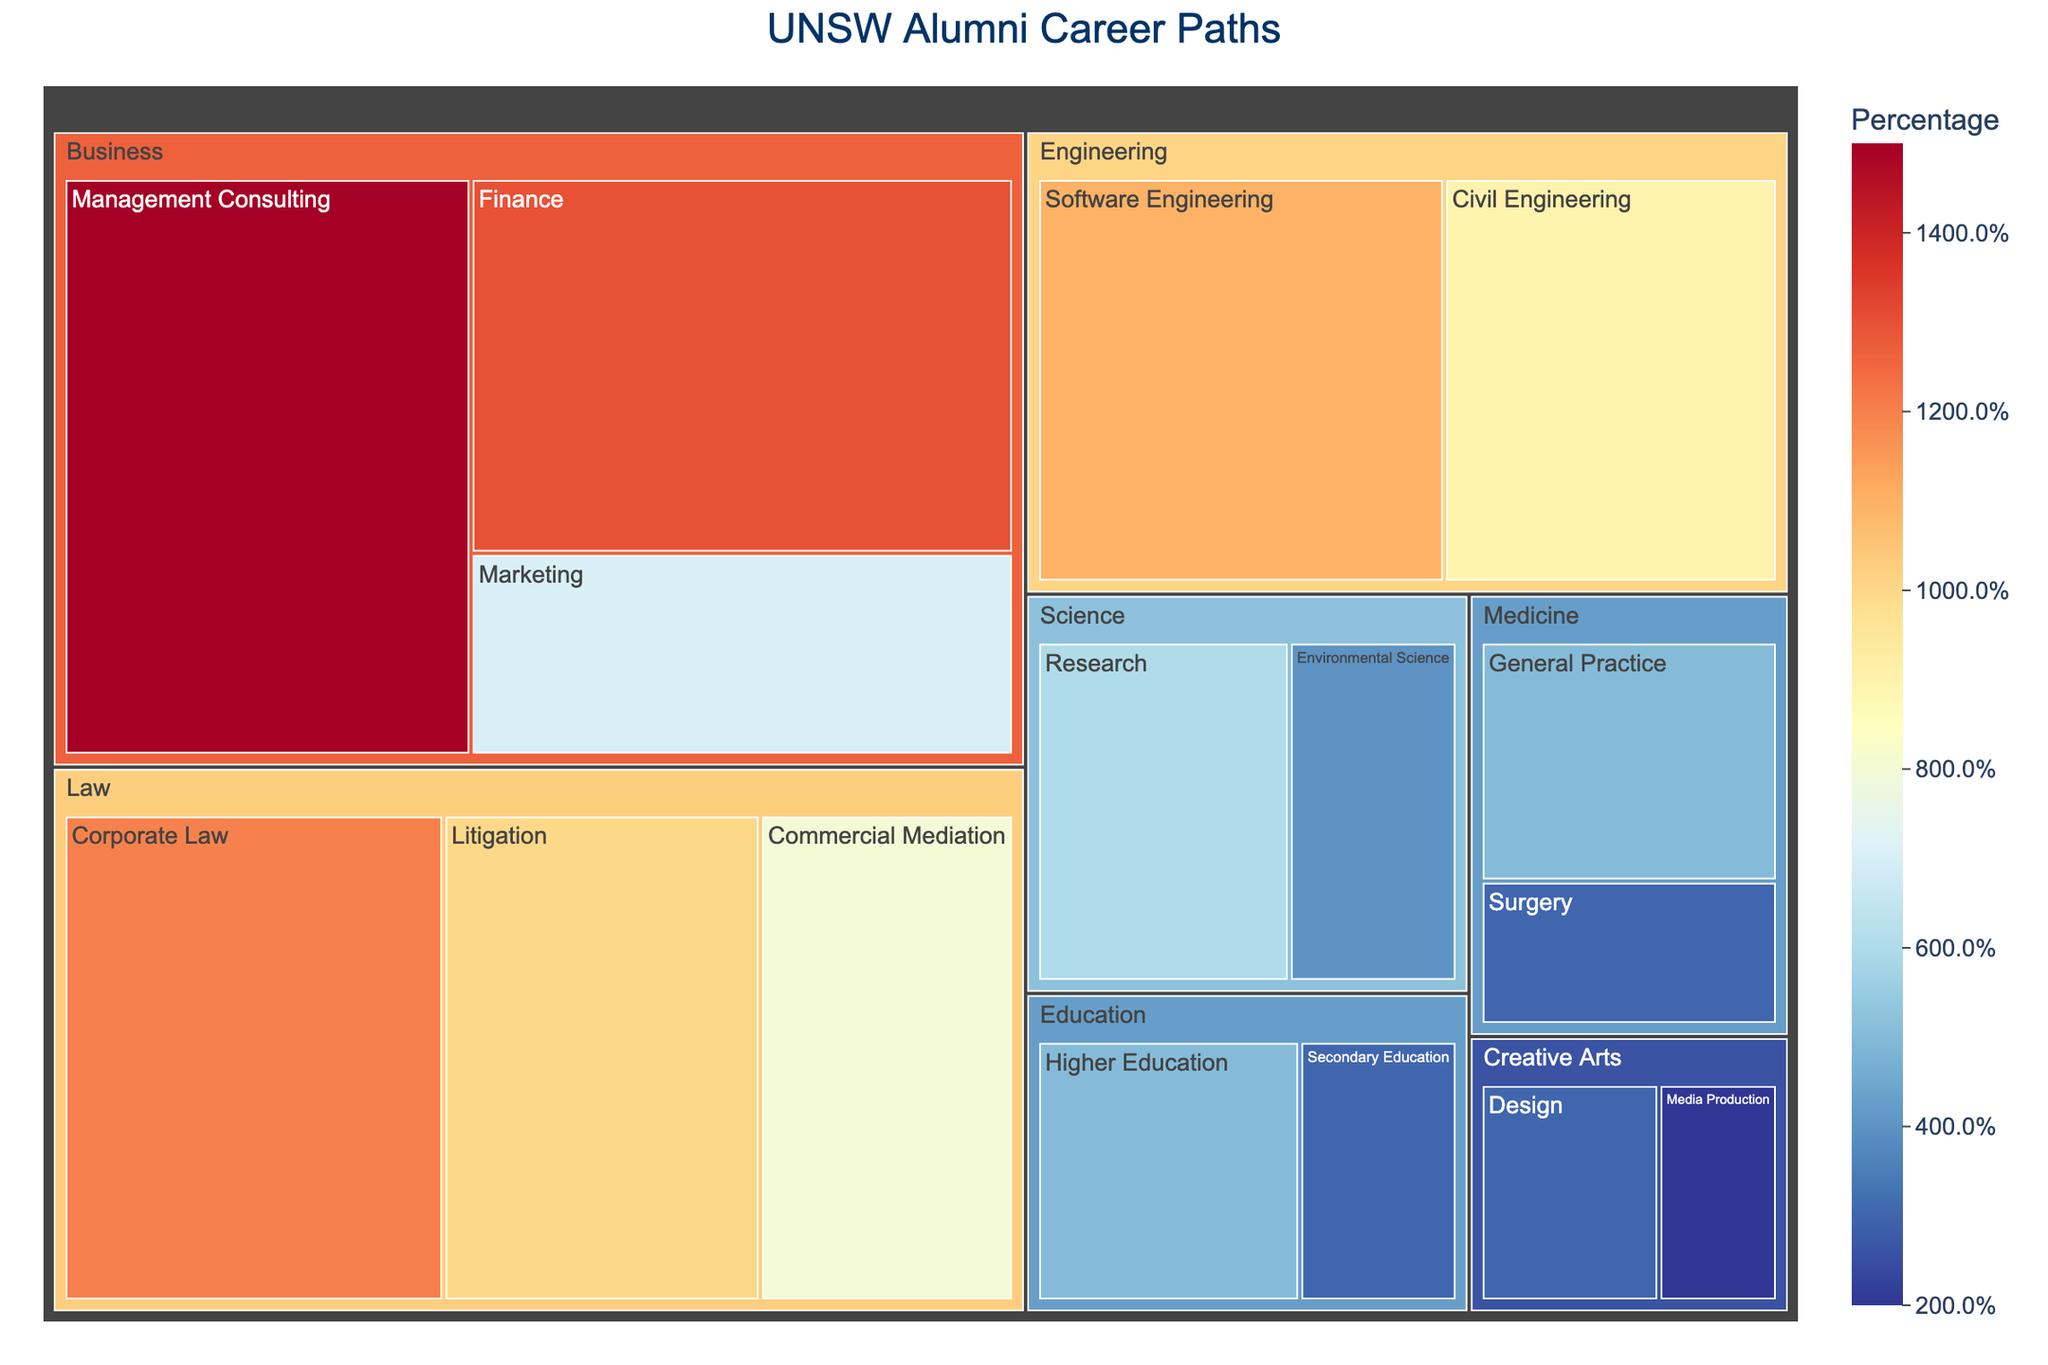What's the title of the figure? The title is shown at the top of the figure, usually in larger and bold font. It provides an overview of what the figure represents.
Answer: UNSW Alumni Career Paths Which career field has the highest percentage of alumni? By looking at the treemap, the size of the boxes within each career field can show relative percentages. The largest box represents the field with the highest percentage.
Answer: Business What is the combined percentage of alumni in the Law field? Combine the percentages of Commercial Mediation, Corporate Law, and Litigation in the Law field. 8% + 12% + 10% = 30%.
Answer: 30% Which subfield within Medicine has more alumni, General Practice or Surgery? Compare the sizes of the boxes for General Practice and Surgery within the Medicine field.
Answer: General Practice Which career field has the smallest representation of alumni? Look for the smallest box among the career fields.
Answer: Creative Arts Compare the percentage of alumni in Civil Engineering and Software Engineering. Which one is higher? Examine the sizes of the boxes within the Engineering field to determine which subfield has a higher percentage.
Answer: Software Engineering What is the combined percentage for all subfields in the Science career field? Add the percentages for Research and Environmental Science within the Science field. 6% + 4% = 10%.
Answer: 10% How does the percentage of alumni in Marketing compare to Media Production? Look at the sizes of the respective subfield boxes within Business and Creative Arts fields to compare their percentages.
Answer: Marketing is higher What percentage of alumni are in the Surgery subfield? Find the Surgery subfield within the Medicine field and read the percentage indicated for this subfield.
Answer: 3% Calculate the total percentage of alumni represented in the Education career field. Sum up the percentages for Higher Education and Secondary Education. 5% + 3% = 8%.
Answer: 8% 